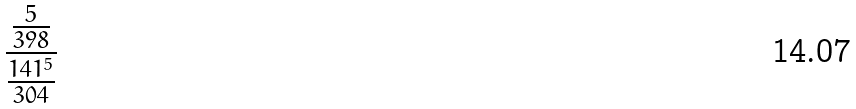<formula> <loc_0><loc_0><loc_500><loc_500>\frac { \frac { 5 } { 3 9 8 } } { \frac { 1 4 1 ^ { 5 } } { 3 0 4 } }</formula> 